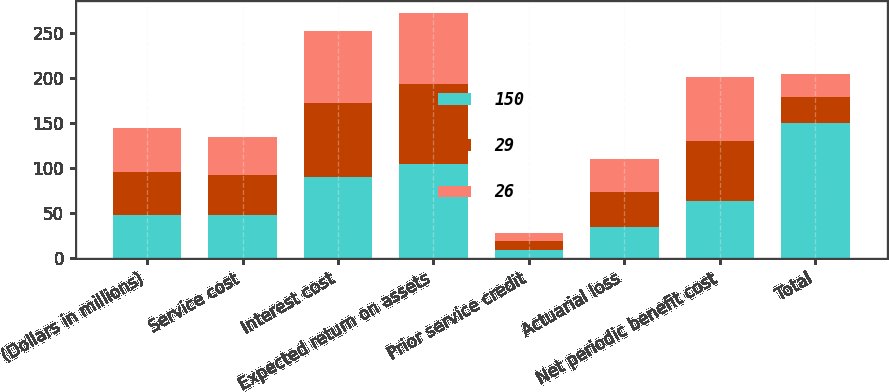Convert chart to OTSL. <chart><loc_0><loc_0><loc_500><loc_500><stacked_bar_chart><ecel><fcel>(Dollars in millions)<fcel>Service cost<fcel>Interest cost<fcel>Expected return on assets<fcel>Prior service credit<fcel>Actuarial loss<fcel>Net periodic benefit cost<fcel>Total<nl><fcel>150<fcel>48<fcel>48<fcel>90<fcel>105<fcel>9<fcel>35<fcel>63<fcel>150<nl><fcel>29<fcel>48<fcel>44<fcel>82<fcel>88<fcel>10<fcel>39<fcel>67<fcel>29<nl><fcel>26<fcel>48<fcel>43<fcel>80<fcel>79<fcel>9<fcel>36<fcel>71<fcel>26<nl></chart> 